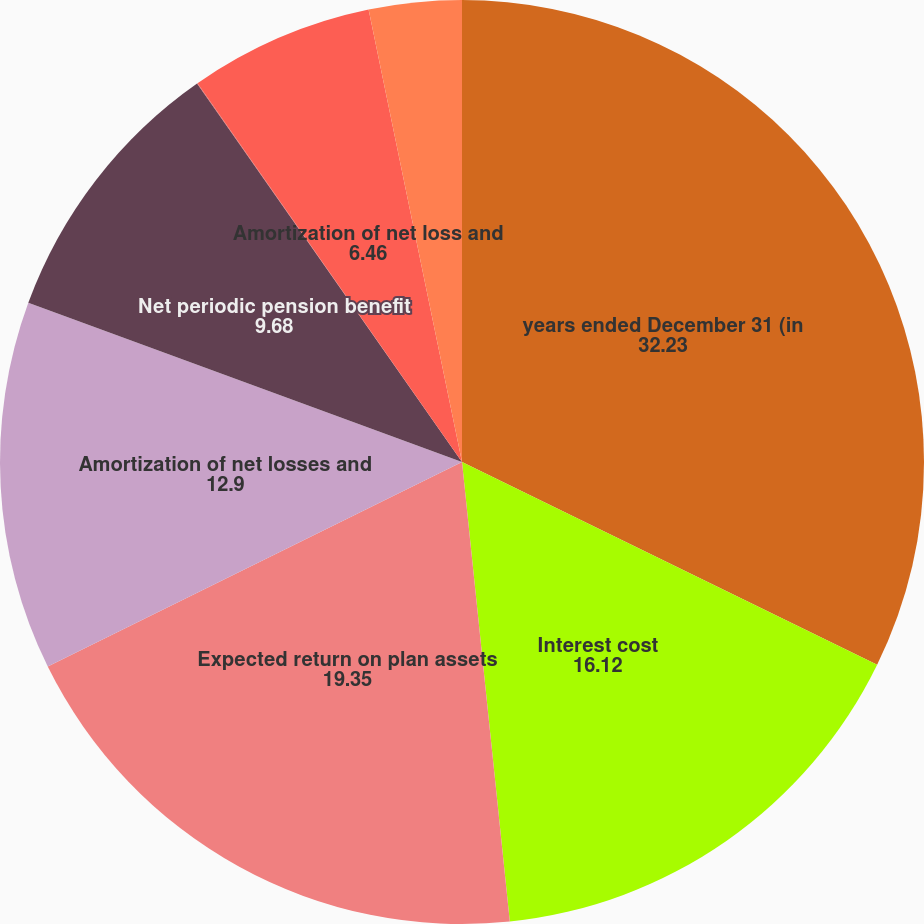Convert chart. <chart><loc_0><loc_0><loc_500><loc_500><pie_chart><fcel>years ended December 31 (in<fcel>Interest cost<fcel>Expected return on plan assets<fcel>Amortization of net losses and<fcel>Net periodic pension benefit<fcel>Service cost<fcel>Amortization of net loss and<fcel>Net periodic OPEB cost<nl><fcel>32.23%<fcel>16.12%<fcel>19.35%<fcel>12.9%<fcel>9.68%<fcel>0.02%<fcel>6.46%<fcel>3.24%<nl></chart> 